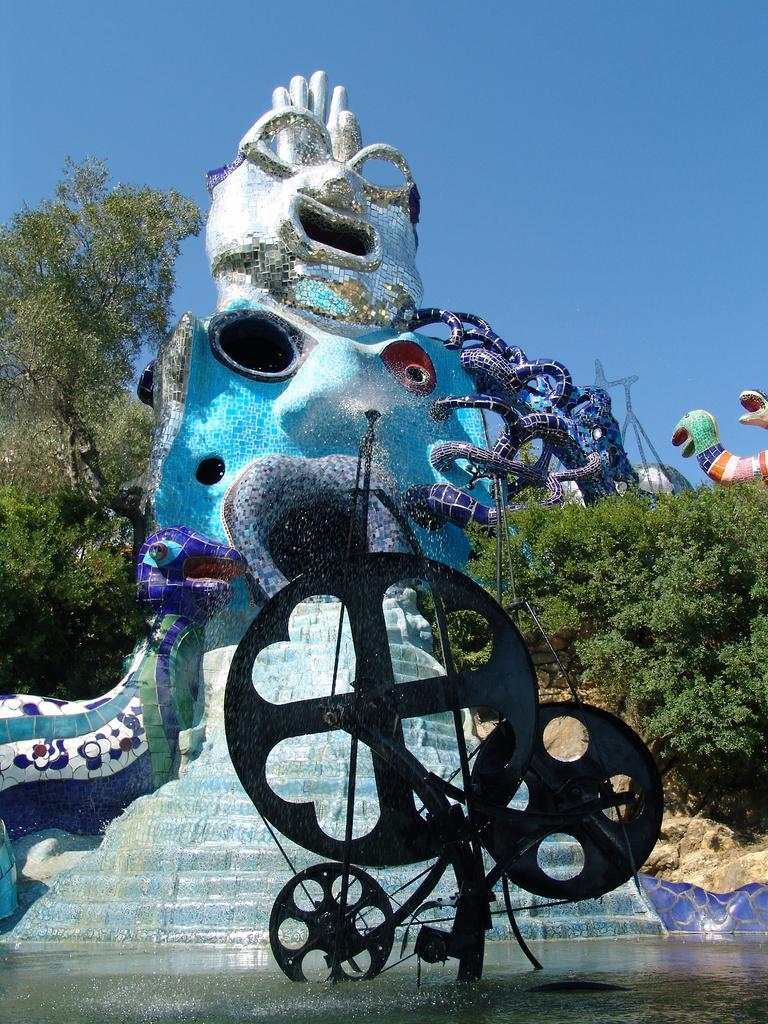How would you summarize this image in a sentence or two? In this image I can see the water and there is an object in the water. To the side of the water I can see the fountain and the blue color statue. To the side of the statue I can see many trees. In the background there is a blue sky. 